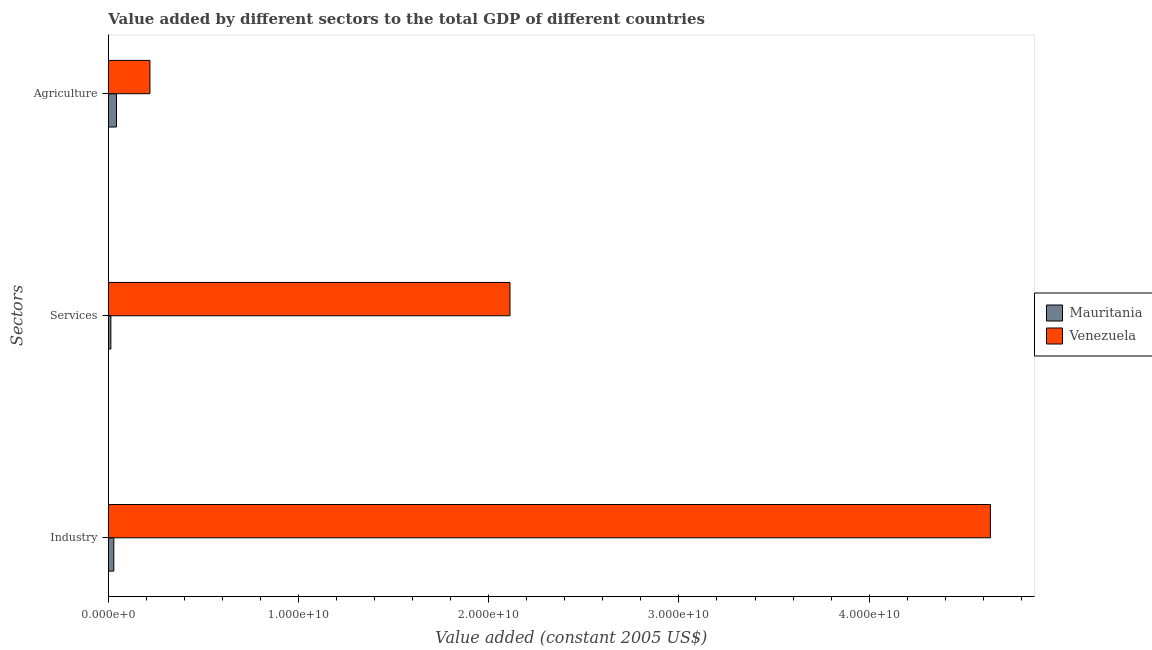How many different coloured bars are there?
Offer a very short reply. 2. How many groups of bars are there?
Keep it short and to the point. 3. Are the number of bars on each tick of the Y-axis equal?
Provide a succinct answer. Yes. What is the label of the 3rd group of bars from the top?
Offer a terse response. Industry. What is the value added by services in Mauritania?
Offer a terse response. 1.28e+08. Across all countries, what is the maximum value added by agricultural sector?
Provide a short and direct response. 2.18e+09. Across all countries, what is the minimum value added by services?
Keep it short and to the point. 1.28e+08. In which country was the value added by agricultural sector maximum?
Your response must be concise. Venezuela. In which country was the value added by agricultural sector minimum?
Provide a short and direct response. Mauritania. What is the total value added by agricultural sector in the graph?
Ensure brevity in your answer.  2.61e+09. What is the difference between the value added by industrial sector in Mauritania and that in Venezuela?
Ensure brevity in your answer.  -4.61e+1. What is the difference between the value added by services in Venezuela and the value added by agricultural sector in Mauritania?
Make the answer very short. 2.07e+1. What is the average value added by agricultural sector per country?
Offer a terse response. 1.30e+09. What is the difference between the value added by services and value added by agricultural sector in Venezuela?
Provide a short and direct response. 1.89e+1. In how many countries, is the value added by agricultural sector greater than 12000000000 US$?
Your response must be concise. 0. What is the ratio of the value added by industrial sector in Mauritania to that in Venezuela?
Offer a very short reply. 0.01. Is the value added by services in Venezuela less than that in Mauritania?
Your response must be concise. No. What is the difference between the highest and the second highest value added by agricultural sector?
Ensure brevity in your answer.  1.76e+09. What is the difference between the highest and the lowest value added by industrial sector?
Make the answer very short. 4.61e+1. What does the 1st bar from the top in Agriculture represents?
Make the answer very short. Venezuela. What does the 1st bar from the bottom in Agriculture represents?
Ensure brevity in your answer.  Mauritania. Is it the case that in every country, the sum of the value added by industrial sector and value added by services is greater than the value added by agricultural sector?
Your answer should be compact. No. Are all the bars in the graph horizontal?
Give a very brief answer. Yes. How many countries are there in the graph?
Your answer should be very brief. 2. Does the graph contain any zero values?
Your response must be concise. No. Does the graph contain grids?
Keep it short and to the point. No. What is the title of the graph?
Your response must be concise. Value added by different sectors to the total GDP of different countries. Does "Kenya" appear as one of the legend labels in the graph?
Ensure brevity in your answer.  No. What is the label or title of the X-axis?
Give a very brief answer. Value added (constant 2005 US$). What is the label or title of the Y-axis?
Ensure brevity in your answer.  Sectors. What is the Value added (constant 2005 US$) in Mauritania in Industry?
Make the answer very short. 2.83e+08. What is the Value added (constant 2005 US$) of Venezuela in Industry?
Make the answer very short. 4.64e+1. What is the Value added (constant 2005 US$) of Mauritania in Services?
Offer a very short reply. 1.28e+08. What is the Value added (constant 2005 US$) in Venezuela in Services?
Your response must be concise. 2.11e+1. What is the Value added (constant 2005 US$) in Mauritania in Agriculture?
Give a very brief answer. 4.24e+08. What is the Value added (constant 2005 US$) in Venezuela in Agriculture?
Give a very brief answer. 2.18e+09. Across all Sectors, what is the maximum Value added (constant 2005 US$) in Mauritania?
Offer a terse response. 4.24e+08. Across all Sectors, what is the maximum Value added (constant 2005 US$) in Venezuela?
Make the answer very short. 4.64e+1. Across all Sectors, what is the minimum Value added (constant 2005 US$) of Mauritania?
Give a very brief answer. 1.28e+08. Across all Sectors, what is the minimum Value added (constant 2005 US$) in Venezuela?
Your response must be concise. 2.18e+09. What is the total Value added (constant 2005 US$) in Mauritania in the graph?
Your answer should be very brief. 8.35e+08. What is the total Value added (constant 2005 US$) in Venezuela in the graph?
Keep it short and to the point. 6.97e+1. What is the difference between the Value added (constant 2005 US$) in Mauritania in Industry and that in Services?
Offer a very short reply. 1.55e+08. What is the difference between the Value added (constant 2005 US$) in Venezuela in Industry and that in Services?
Provide a short and direct response. 2.53e+1. What is the difference between the Value added (constant 2005 US$) in Mauritania in Industry and that in Agriculture?
Offer a very short reply. -1.40e+08. What is the difference between the Value added (constant 2005 US$) of Venezuela in Industry and that in Agriculture?
Provide a succinct answer. 4.42e+1. What is the difference between the Value added (constant 2005 US$) in Mauritania in Services and that in Agriculture?
Offer a very short reply. -2.95e+08. What is the difference between the Value added (constant 2005 US$) in Venezuela in Services and that in Agriculture?
Your answer should be compact. 1.89e+1. What is the difference between the Value added (constant 2005 US$) of Mauritania in Industry and the Value added (constant 2005 US$) of Venezuela in Services?
Your answer should be very brief. -2.08e+1. What is the difference between the Value added (constant 2005 US$) of Mauritania in Industry and the Value added (constant 2005 US$) of Venezuela in Agriculture?
Offer a very short reply. -1.90e+09. What is the difference between the Value added (constant 2005 US$) in Mauritania in Services and the Value added (constant 2005 US$) in Venezuela in Agriculture?
Your response must be concise. -2.06e+09. What is the average Value added (constant 2005 US$) in Mauritania per Sectors?
Your response must be concise. 2.78e+08. What is the average Value added (constant 2005 US$) in Venezuela per Sectors?
Offer a terse response. 2.32e+1. What is the difference between the Value added (constant 2005 US$) in Mauritania and Value added (constant 2005 US$) in Venezuela in Industry?
Provide a short and direct response. -4.61e+1. What is the difference between the Value added (constant 2005 US$) in Mauritania and Value added (constant 2005 US$) in Venezuela in Services?
Give a very brief answer. -2.10e+1. What is the difference between the Value added (constant 2005 US$) in Mauritania and Value added (constant 2005 US$) in Venezuela in Agriculture?
Keep it short and to the point. -1.76e+09. What is the ratio of the Value added (constant 2005 US$) of Mauritania in Industry to that in Services?
Your answer should be very brief. 2.21. What is the ratio of the Value added (constant 2005 US$) in Venezuela in Industry to that in Services?
Offer a very short reply. 2.2. What is the ratio of the Value added (constant 2005 US$) in Mauritania in Industry to that in Agriculture?
Provide a succinct answer. 0.67. What is the ratio of the Value added (constant 2005 US$) of Venezuela in Industry to that in Agriculture?
Provide a short and direct response. 21.24. What is the ratio of the Value added (constant 2005 US$) of Mauritania in Services to that in Agriculture?
Offer a terse response. 0.3. What is the ratio of the Value added (constant 2005 US$) in Venezuela in Services to that in Agriculture?
Provide a short and direct response. 9.67. What is the difference between the highest and the second highest Value added (constant 2005 US$) in Mauritania?
Give a very brief answer. 1.40e+08. What is the difference between the highest and the second highest Value added (constant 2005 US$) of Venezuela?
Provide a succinct answer. 2.53e+1. What is the difference between the highest and the lowest Value added (constant 2005 US$) in Mauritania?
Make the answer very short. 2.95e+08. What is the difference between the highest and the lowest Value added (constant 2005 US$) of Venezuela?
Offer a very short reply. 4.42e+1. 